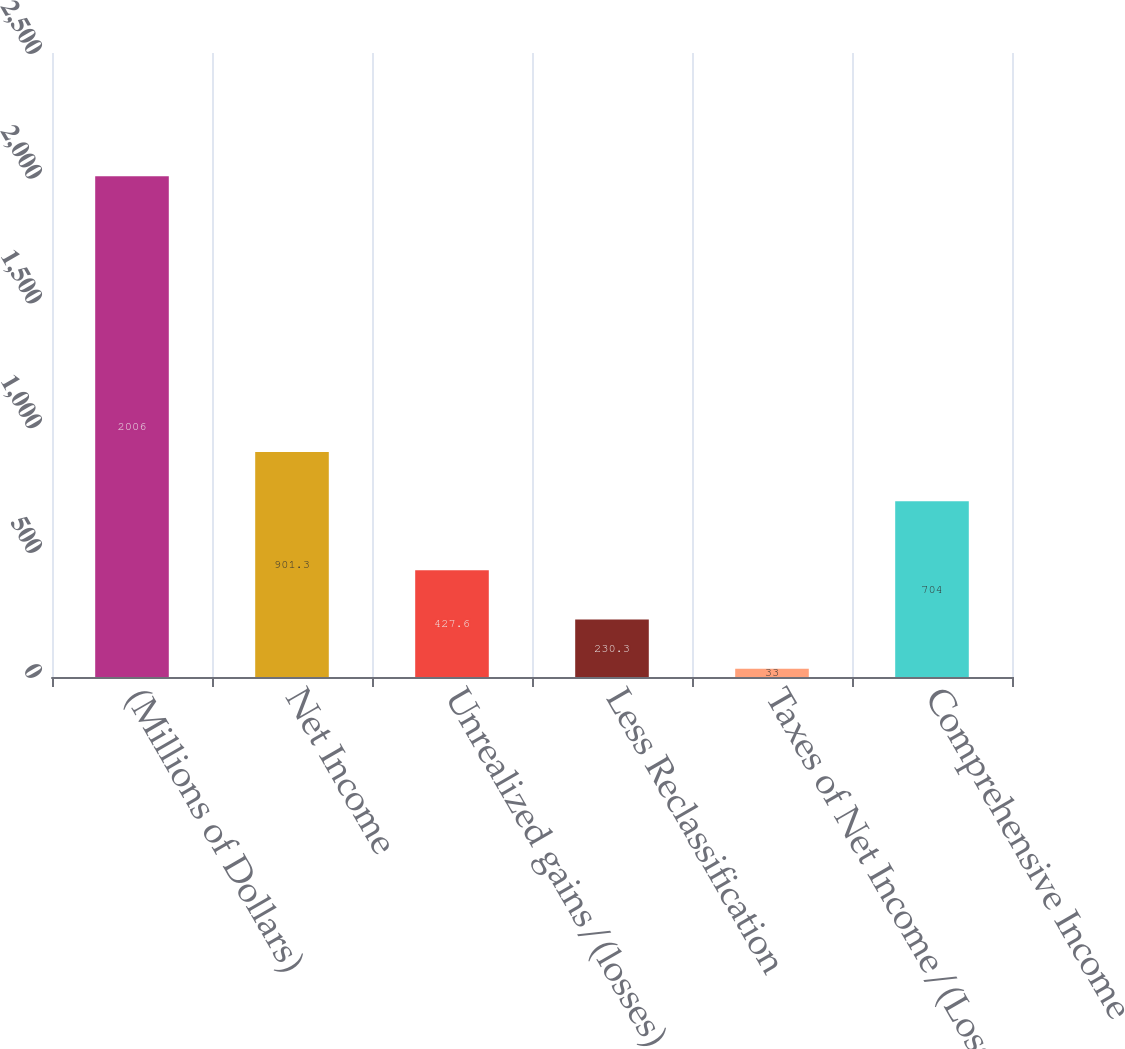Convert chart to OTSL. <chart><loc_0><loc_0><loc_500><loc_500><bar_chart><fcel>(Millions of Dollars)<fcel>Net Income<fcel>Unrealized gains/(losses) on<fcel>Less Reclassification<fcel>Taxes of Net Income/(Loss)<fcel>Comprehensive Income<nl><fcel>2006<fcel>901.3<fcel>427.6<fcel>230.3<fcel>33<fcel>704<nl></chart> 